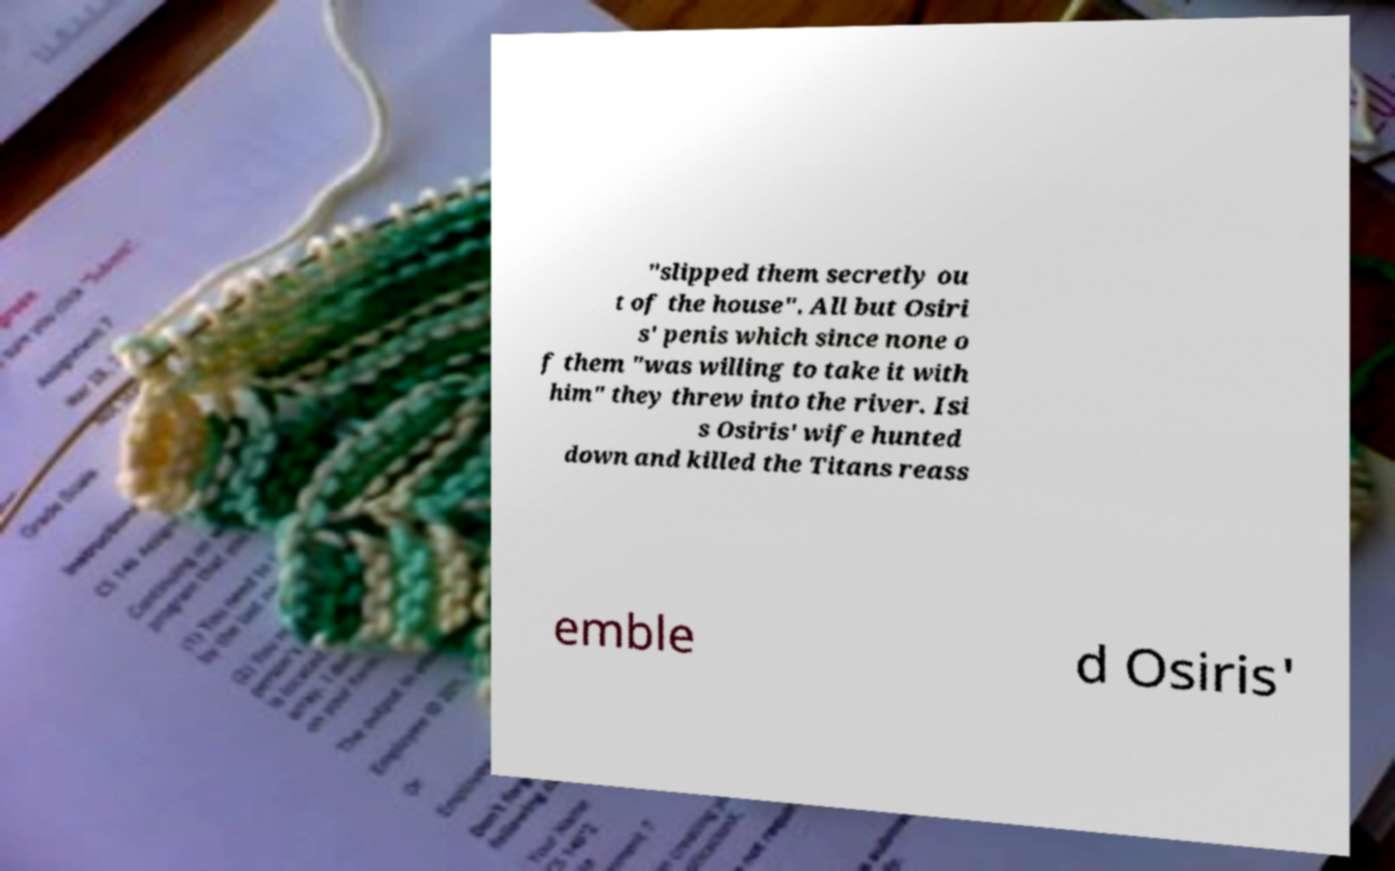Please identify and transcribe the text found in this image. "slipped them secretly ou t of the house". All but Osiri s' penis which since none o f them "was willing to take it with him" they threw into the river. Isi s Osiris' wife hunted down and killed the Titans reass emble d Osiris' 